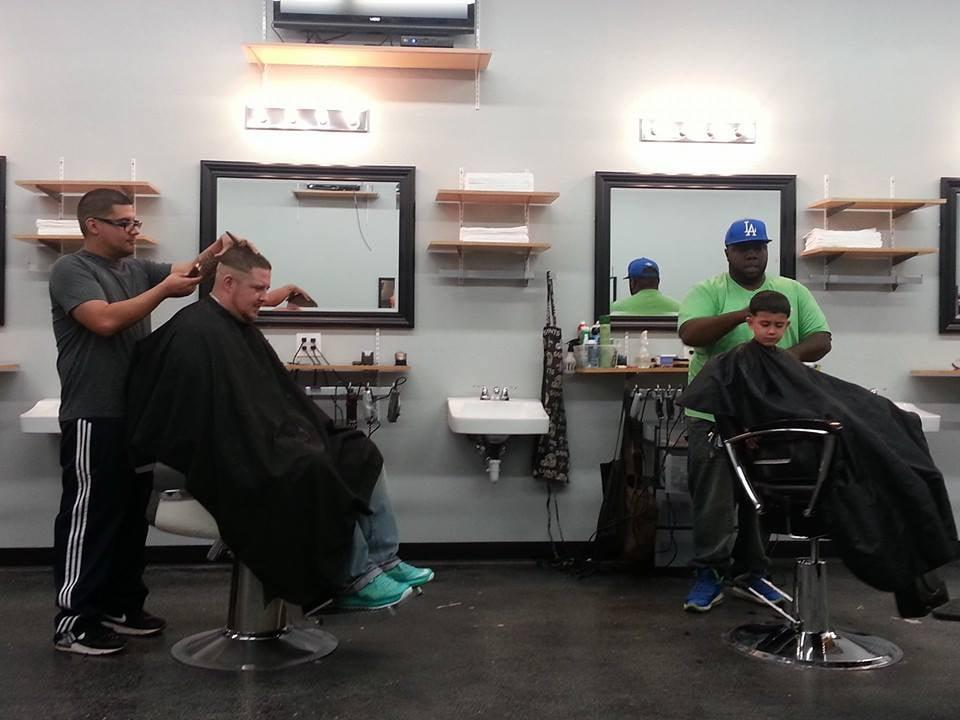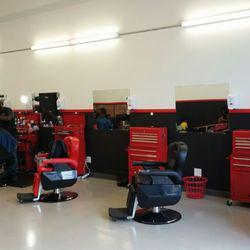The first image is the image on the left, the second image is the image on the right. For the images shown, is this caption "An image shows a row of red and black barber chairs, without customers in the chairs in the foreground." true? Answer yes or no. Yes. 